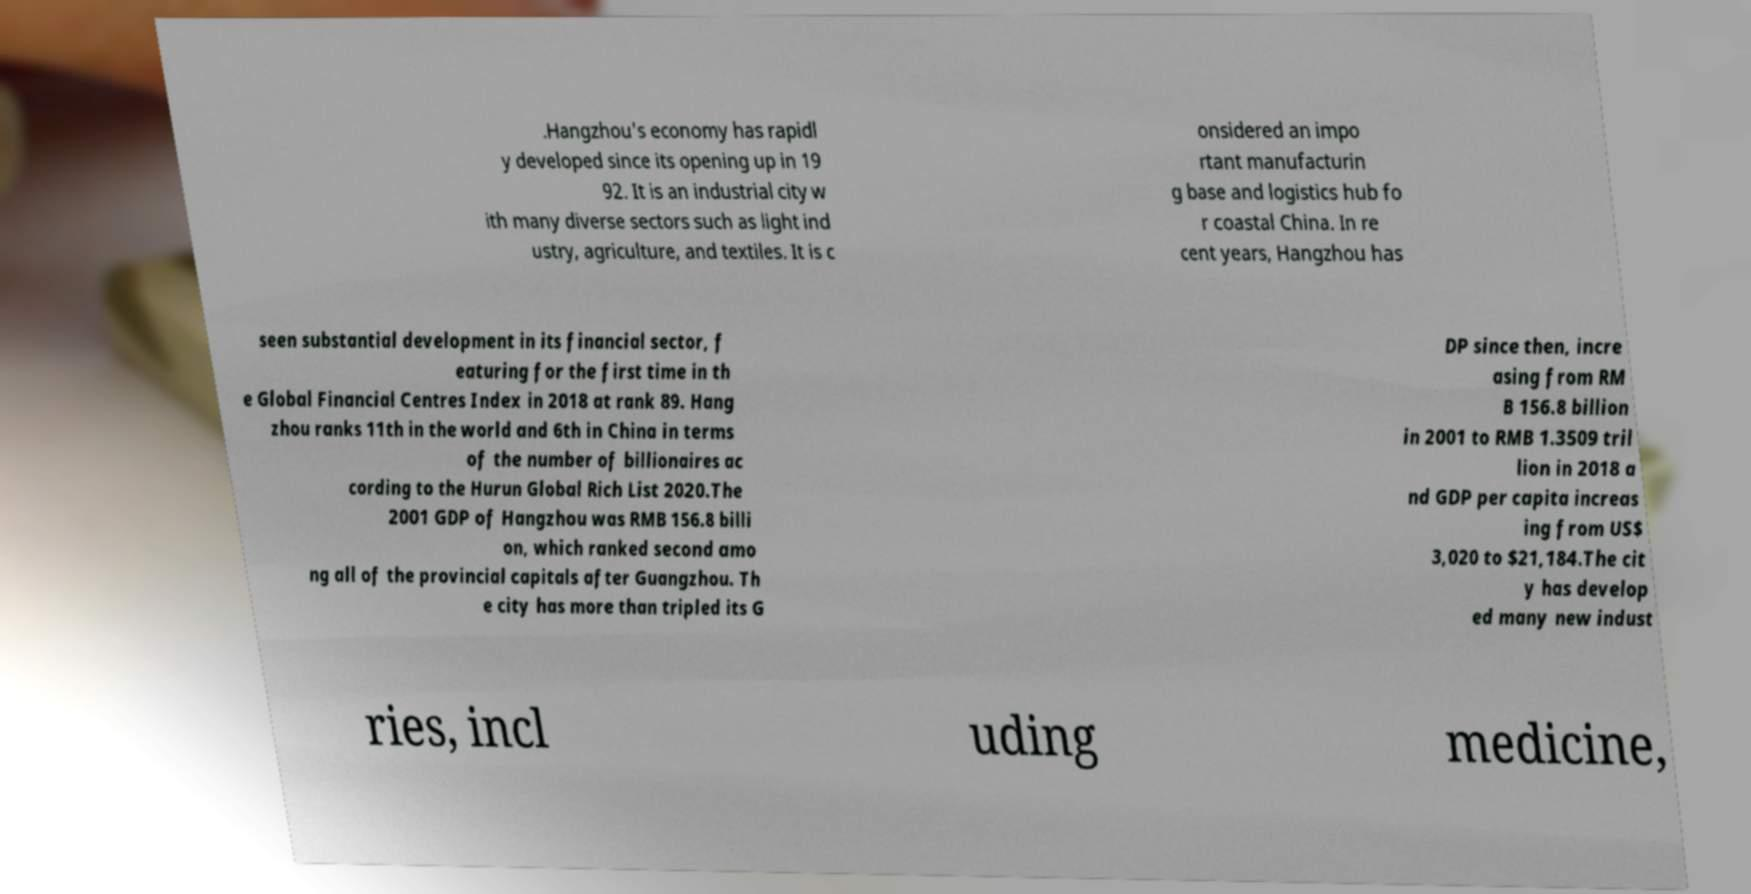For documentation purposes, I need the text within this image transcribed. Could you provide that? .Hangzhou's economy has rapidl y developed since its opening up in 19 92. It is an industrial city w ith many diverse sectors such as light ind ustry, agriculture, and textiles. It is c onsidered an impo rtant manufacturin g base and logistics hub fo r coastal China. In re cent years, Hangzhou has seen substantial development in its financial sector, f eaturing for the first time in th e Global Financial Centres Index in 2018 at rank 89. Hang zhou ranks 11th in the world and 6th in China in terms of the number of billionaires ac cording to the Hurun Global Rich List 2020.The 2001 GDP of Hangzhou was RMB 156.8 billi on, which ranked second amo ng all of the provincial capitals after Guangzhou. Th e city has more than tripled its G DP since then, incre asing from RM B 156.8 billion in 2001 to RMB 1.3509 tril lion in 2018 a nd GDP per capita increas ing from US$ 3,020 to $21,184.The cit y has develop ed many new indust ries, incl uding medicine, 